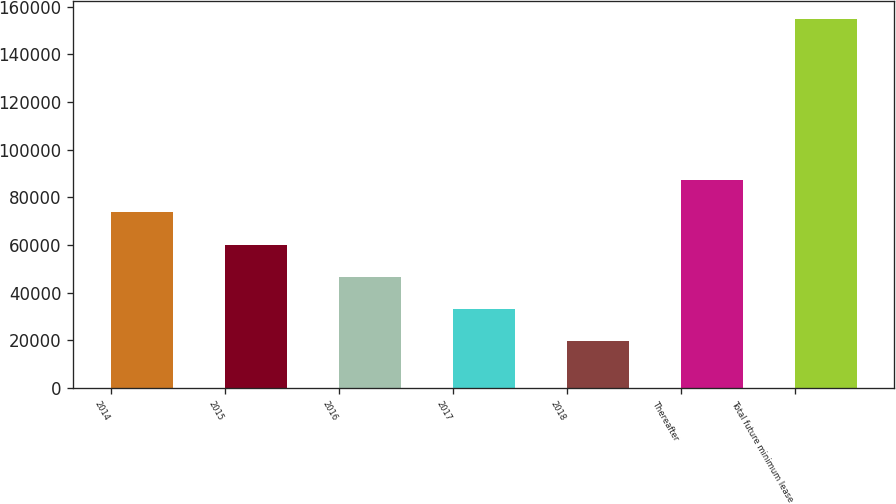Convert chart to OTSL. <chart><loc_0><loc_0><loc_500><loc_500><bar_chart><fcel>2014<fcel>2015<fcel>2016<fcel>2017<fcel>2018<fcel>Thereafter<fcel>Total future minimum lease<nl><fcel>73645.4<fcel>60152.8<fcel>46660.2<fcel>33167.6<fcel>19675<fcel>87138<fcel>154601<nl></chart> 